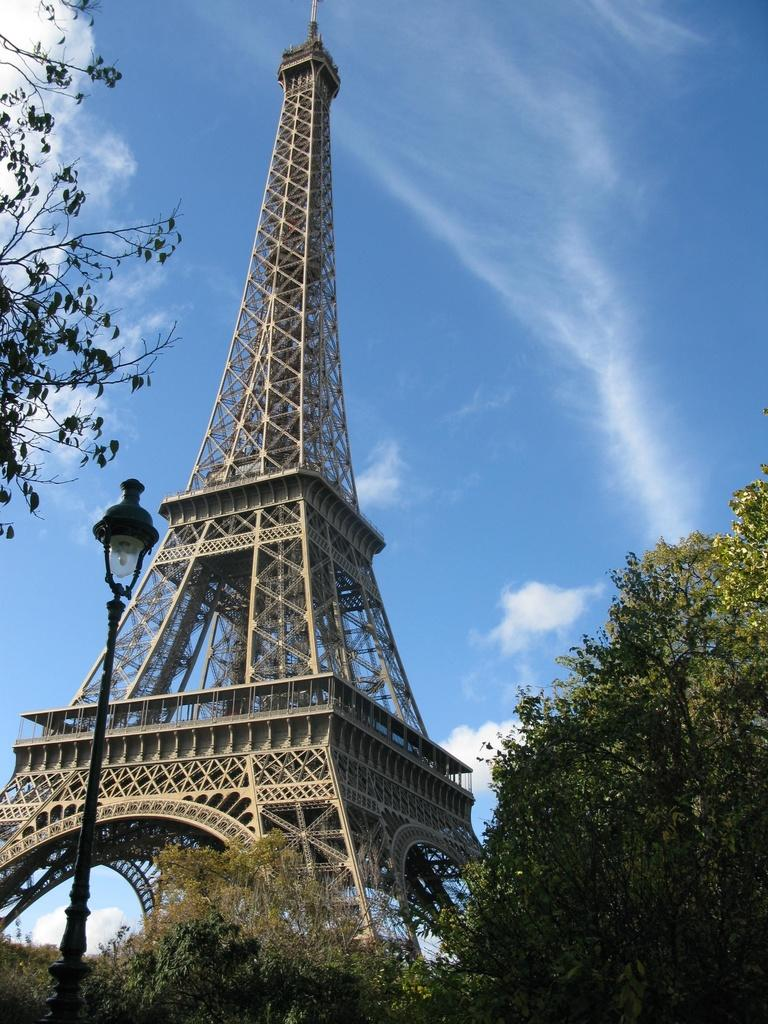What is the color of the sky in the image? The sky in the image is clear and blue. Are there any additional features in the sky besides its color? Yes, there are clouds visible in the sky. What type of vegetation can be seen in the image? There are trees in the image. What kind of light source is present in the image? There is a light with a pole in the image. What is the main focus of the image? The image is mainly highlighted by a tower. How many giants are holding tomatoes in the image? There are no giants or tomatoes present in the image. What type of drug can be seen in the image? There is no drug present in the image. 